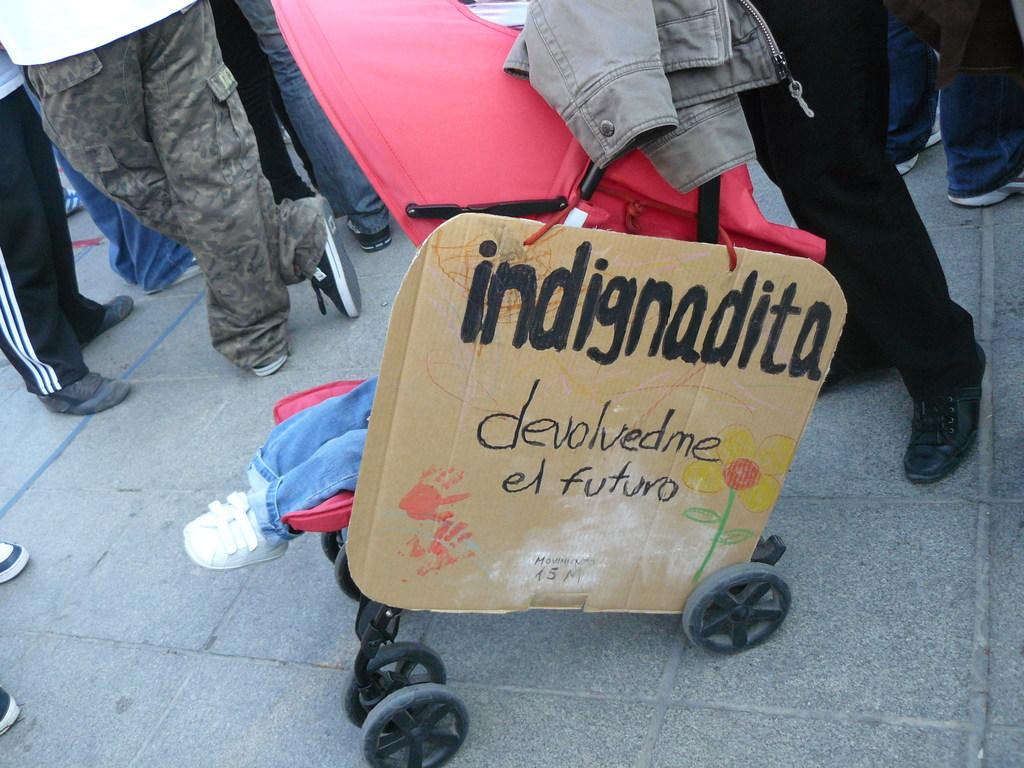What is the main object in the image? There is a board in the image. What else can be seen in the image besides the board? There is a cloth on a stroller and legs of people visible on the ground in the image. What type of hat is the self wearing in the image? There is no self or hat present in the image. 